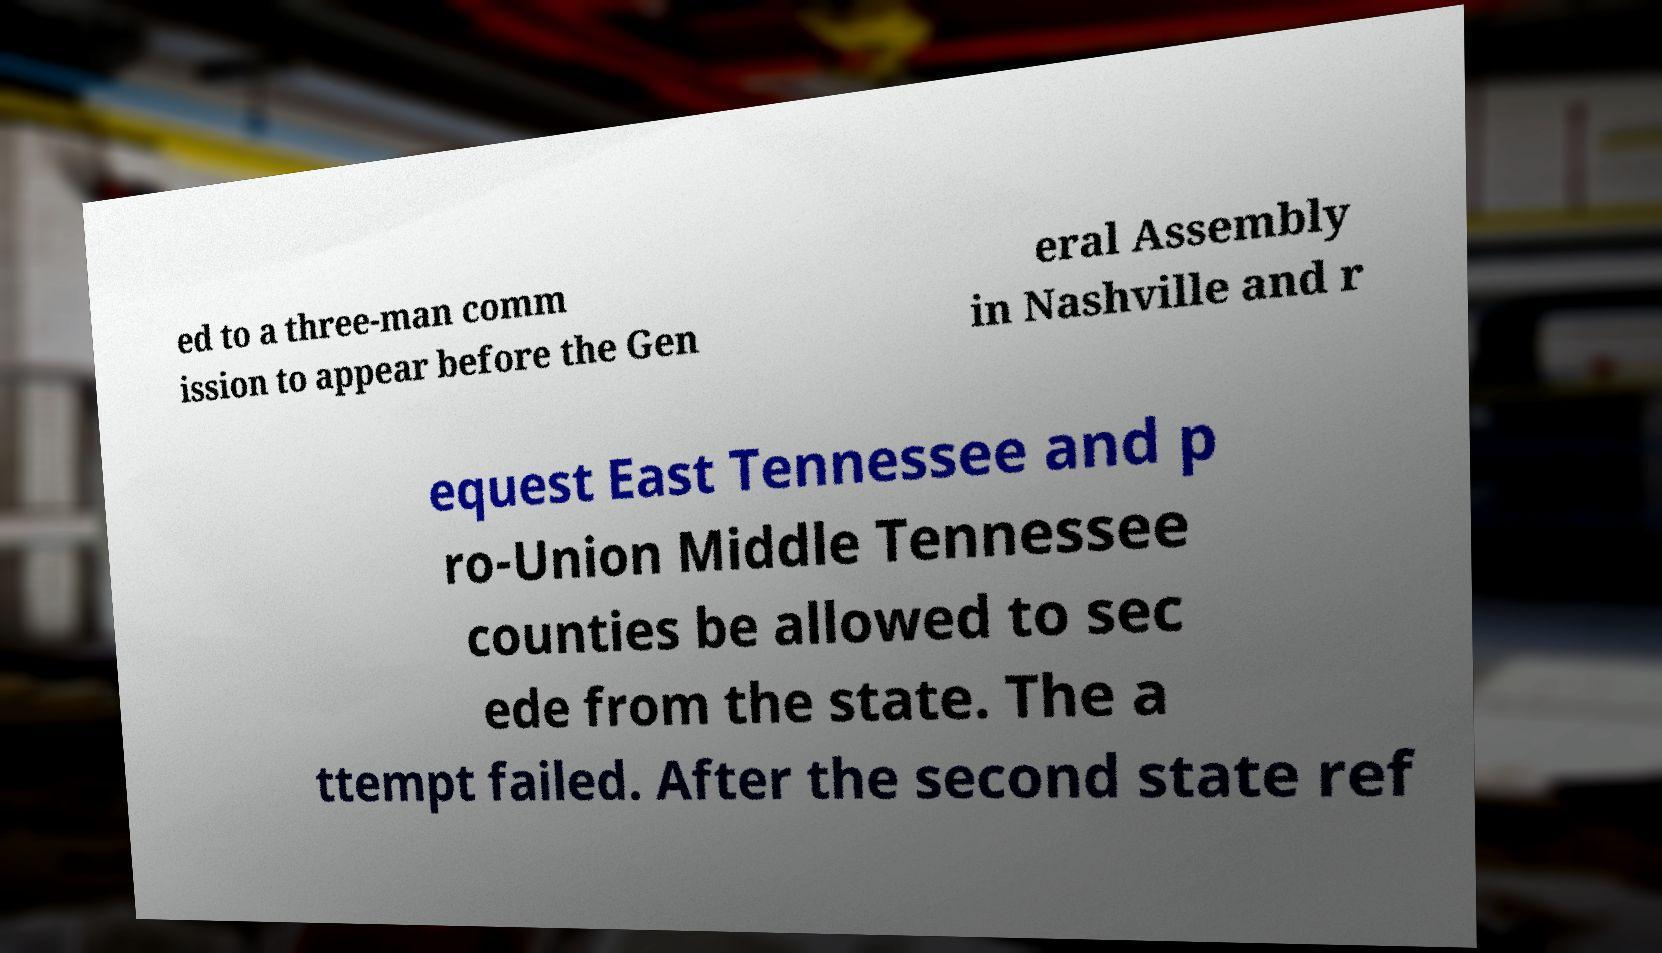Please identify and transcribe the text found in this image. ed to a three-man comm ission to appear before the Gen eral Assembly in Nashville and r equest East Tennessee and p ro-Union Middle Tennessee counties be allowed to sec ede from the state. The a ttempt failed. After the second state ref 